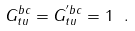<formula> <loc_0><loc_0><loc_500><loc_500>G _ { t u } ^ { b c } = G _ { t u } ^ { ^ { \prime } b c } = 1 \ .</formula> 